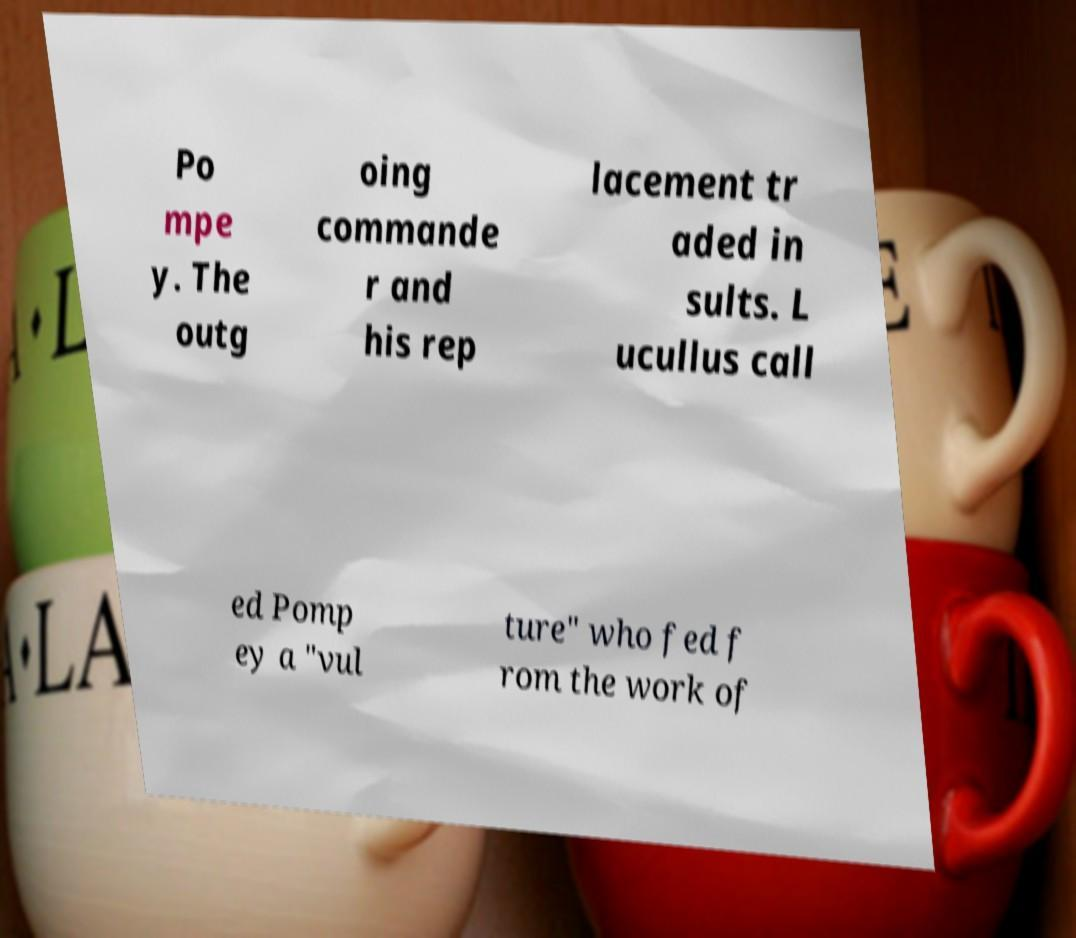Please read and relay the text visible in this image. What does it say? Po mpe y. The outg oing commande r and his rep lacement tr aded in sults. L ucullus call ed Pomp ey a "vul ture" who fed f rom the work of 